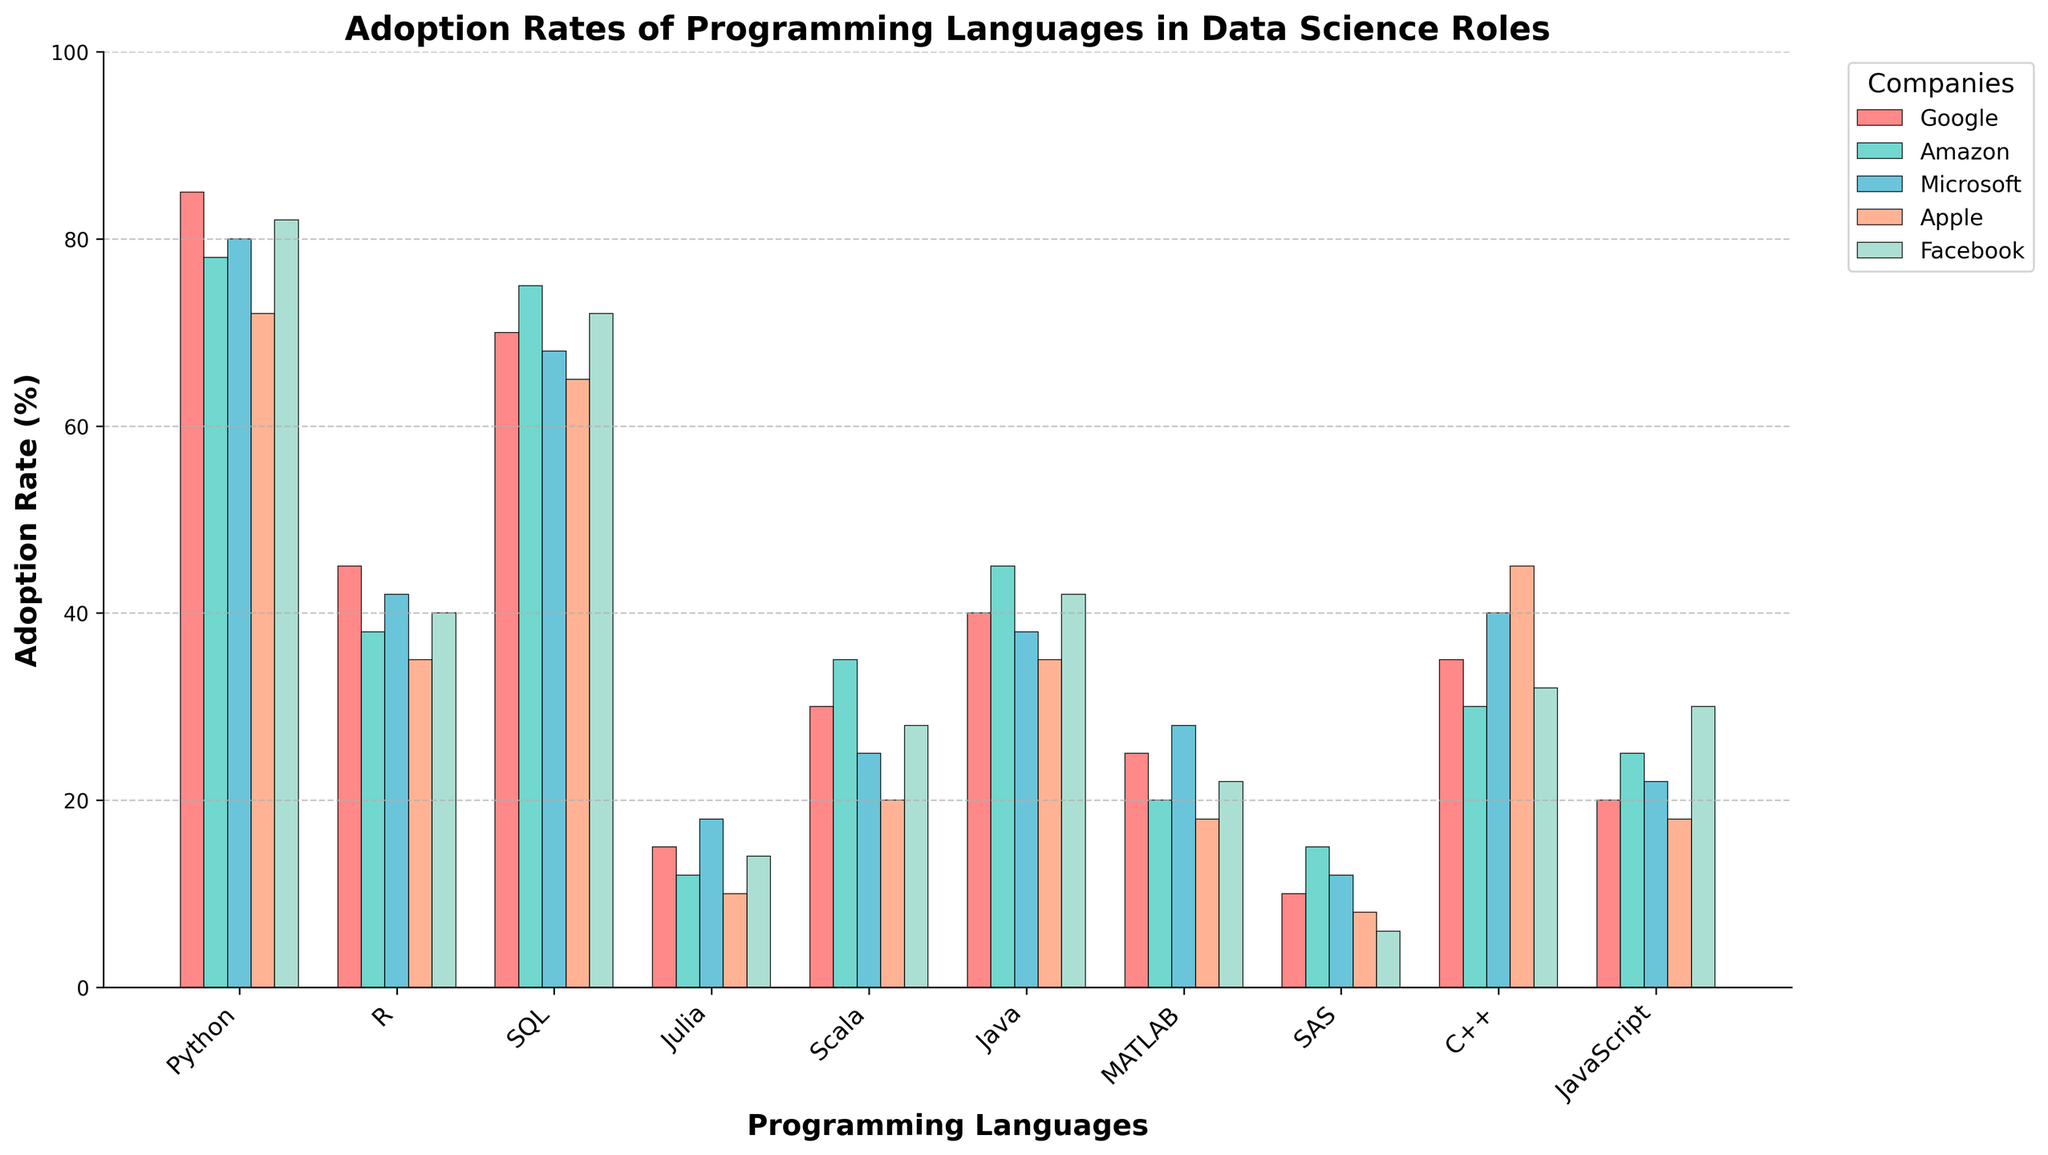What's the most adopted programming language across these companies? Identify the tallest bar in each cluster. Python has the highest adoption rates across all bars.
Answer: Python Which company has the highest adoption rate for Julia? Find the bar representing Julia and identify the tallest bar within this category. Microsoft has the highest adoption rate for Julia.
Answer: Microsoft How does the adoption rate of SAS compare to MATLAB at Apple? Compare the heights of the bars for SAS and MATLAB at Apple. SAS has a lower adoption rate than MATLAB at Apple.
Answer: Lower What is the sum of adoption rates for Scala across all companies? Add the heights of the Scala bars for Google, Amazon, Microsoft, Apple, and Facebook. 30 + 35 + 25 + 20 + 28 = 138.
Answer: 138 Which company sees the smallest difference in adoption rates between Python and R? Calculate the difference between adoption rates for Python and R for each company. Microsoft has the smallest difference (80 - 42 = 38).
Answer: Microsoft What is the average adoption rate of JavaScript across the companies? Add the heights of the JavaScript bars and divide by the number of companies. (20 + 25 + 22 + 18 + 30) / 5 = 115 / 5 = 23.
Answer: 23 Which language has the most consistent adoption rate across all companies? Identify the language with the least variation in bar heights. SQL shows the most consistent adoption rates.
Answer: SQL Compare the adoption rates of Java and C++ at Facebook. Which is higher? Compare the heights of the Java and C++ bars at Facebook. Java has a higher adoption rate at Facebook.
Answer: Java In which company is Python's adoption rate the lowest? Identify the shortest Python bar across the companies. Apple's bar is the shortest for Python.
Answer: Apple 